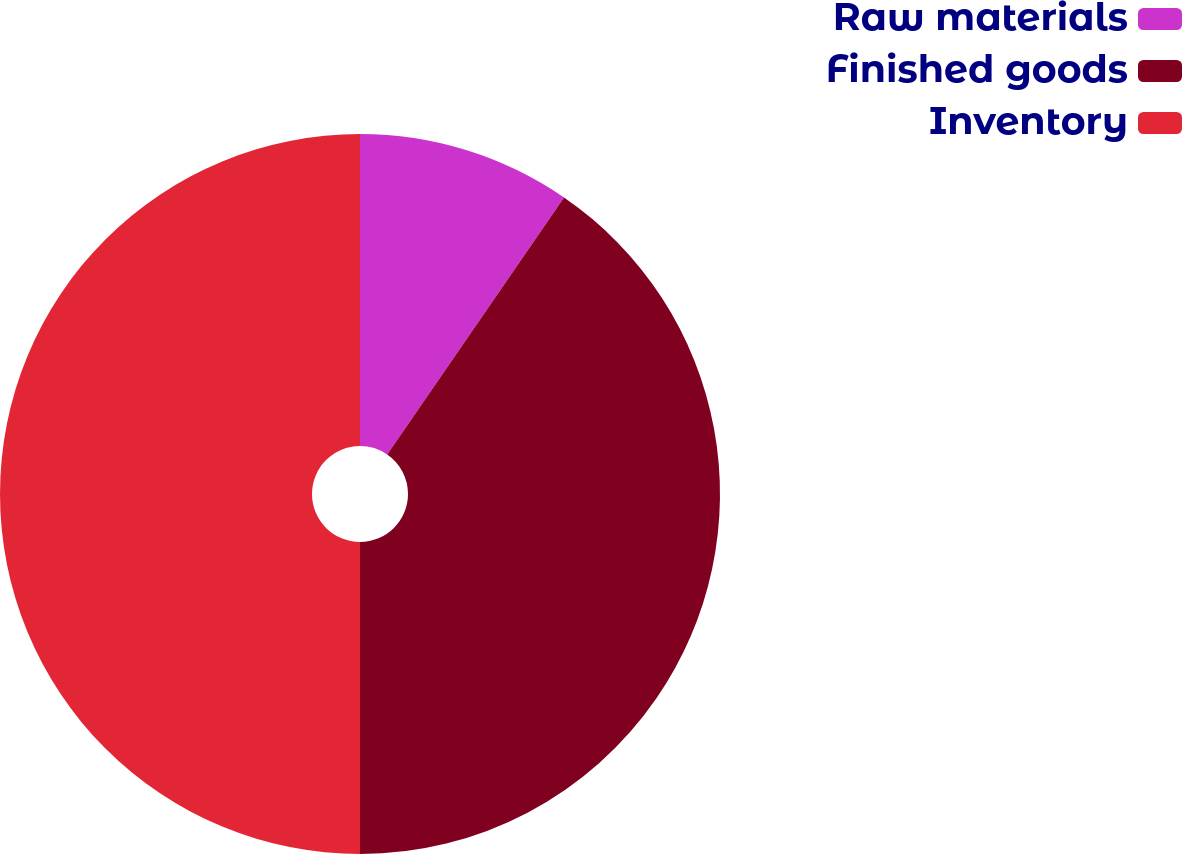Convert chart. <chart><loc_0><loc_0><loc_500><loc_500><pie_chart><fcel>Raw materials<fcel>Finished goods<fcel>Inventory<nl><fcel>9.59%<fcel>40.41%<fcel>50.0%<nl></chart> 